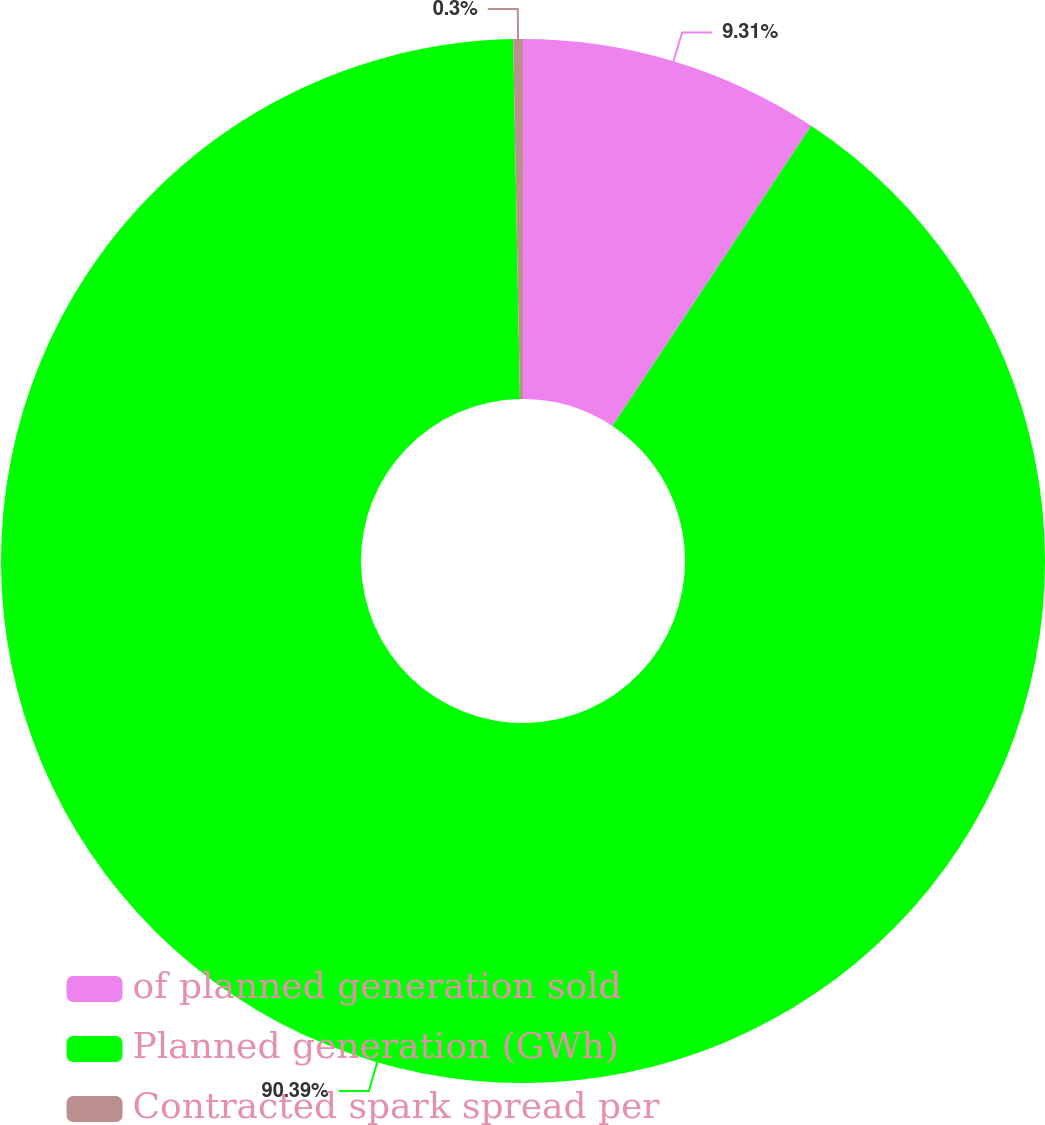<chart> <loc_0><loc_0><loc_500><loc_500><pie_chart><fcel>of planned generation sold<fcel>Planned generation (GWh)<fcel>Contracted spark spread per<nl><fcel>9.31%<fcel>90.4%<fcel>0.3%<nl></chart> 